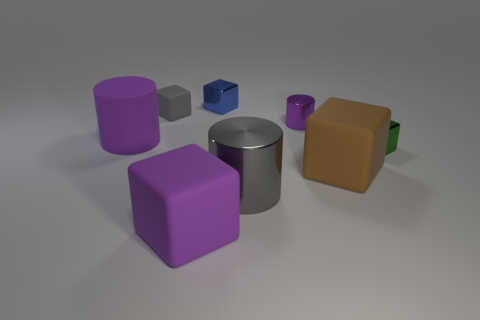Subtract 2 cubes. How many cubes are left? 3 Subtract all green cubes. How many cubes are left? 4 Subtract all tiny gray blocks. How many blocks are left? 4 Subtract all red blocks. Subtract all green balls. How many blocks are left? 5 Add 2 gray rubber cylinders. How many objects exist? 10 Subtract all blocks. How many objects are left? 3 Add 2 large blocks. How many large blocks exist? 4 Subtract 0 cyan cubes. How many objects are left? 8 Subtract all small brown spheres. Subtract all gray rubber things. How many objects are left? 7 Add 4 large brown matte things. How many large brown matte things are left? 5 